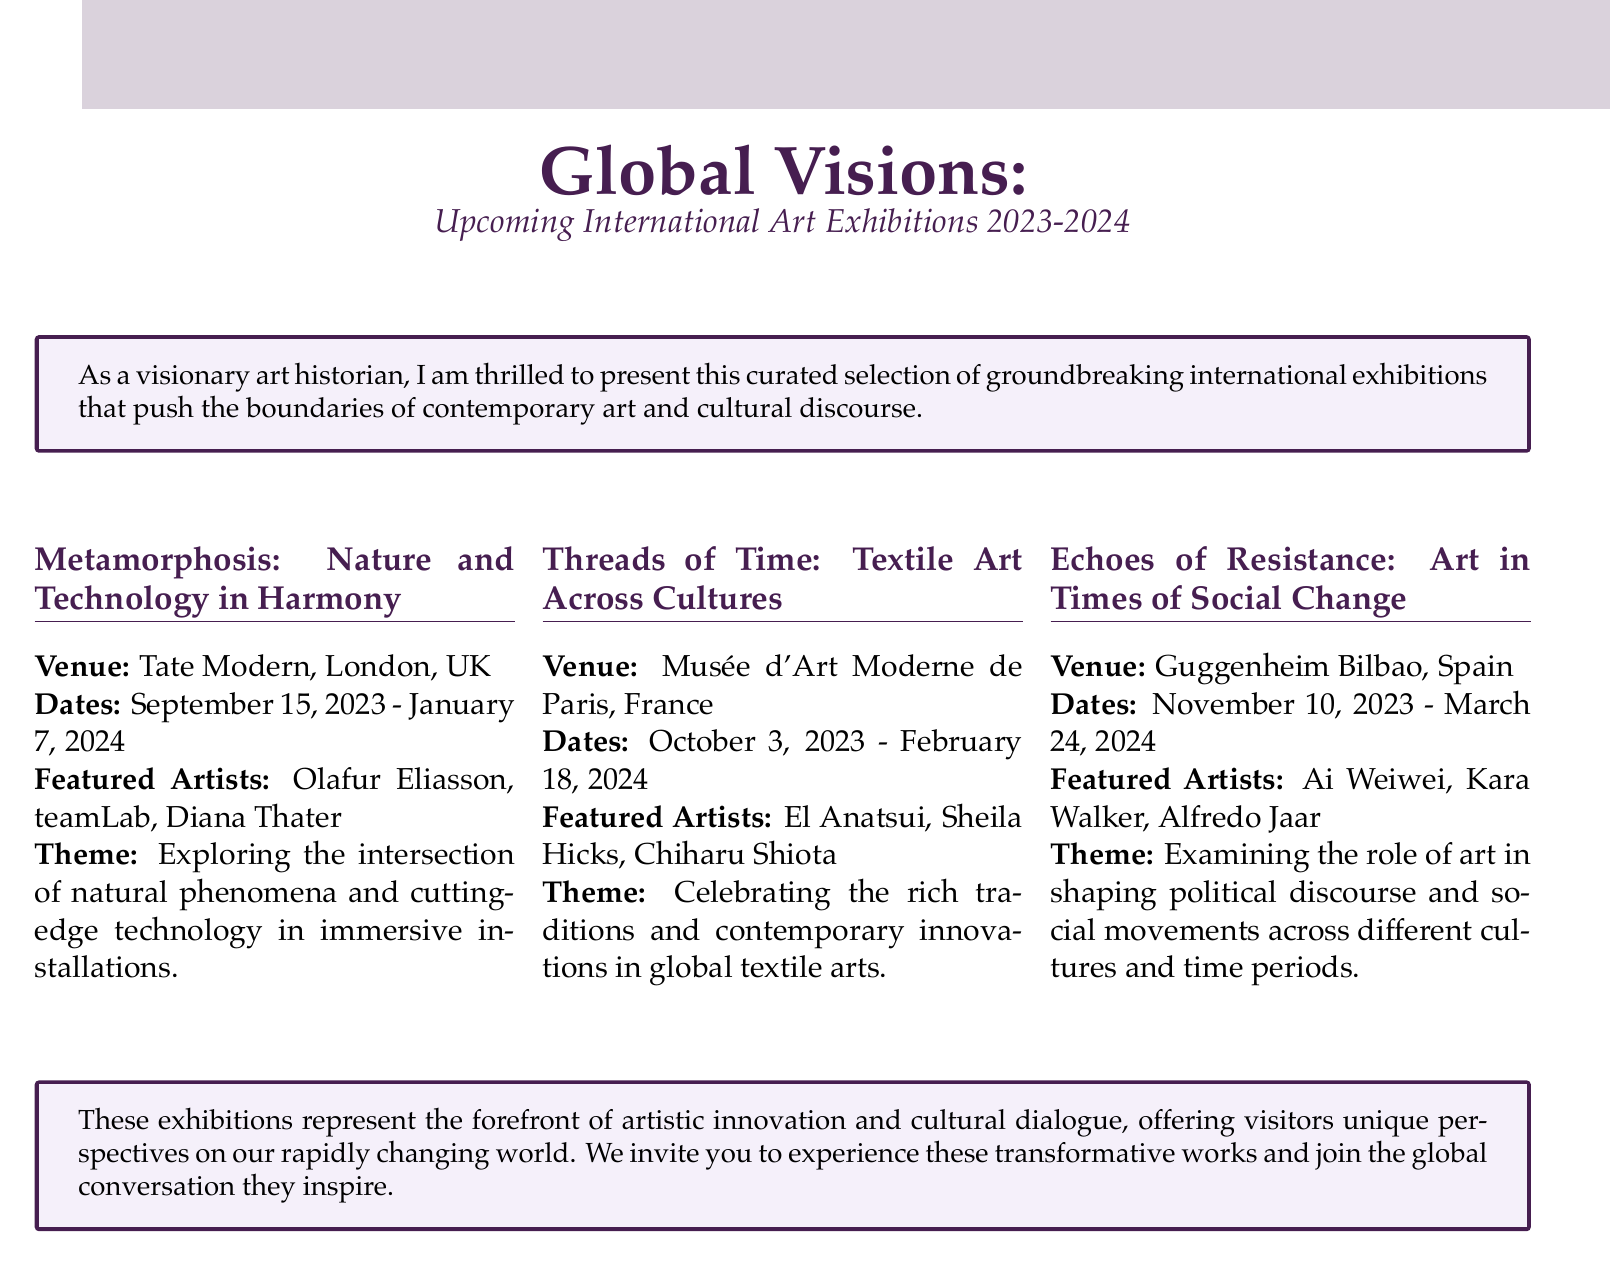What is the title of the catalog? The title is presented at the top of the document, summarizing its content.
Answer: Global Visions: Upcoming International Art Exhibitions 2023-2024 How long will the exhibition at Tate Modern be open? The document states the opening and closing dates for the exhibition at Tate Modern.
Answer: 115 days Who is a featured artist in the "Metamorphosis" exhibition? The document lists several artists featured in the exhibition at Tate Modern.
Answer: Olafur Eliasson What is the theme of the exhibition at the Musée d'Art Moderne de Paris? The theme is specified for each exhibition, providing insight into its focus.
Answer: Celebrating the rich traditions and contemporary innovations in global textile arts Which venue hosts the "Echoes of Resistance" exhibition? The venue is clearly mentioned in the context of each exhibition.
Answer: Guggenheim Bilbao How many featured artists are listed for the "Threads of Time" exhibition? The document provides the number of artists listed under each exhibition's featured artists section.
Answer: 3 What dates does the "Echoes of Resistance" exhibition run? The document specifies the start and end dates for this exhibition.
Answer: November 10, 2023 - March 24, 2024 Which artist is featured in the "Echoes of Resistance" exhibition? The document indicates notable artists associated with this exhibition.
Answer: Ai Weiwei What kind of themes do these exhibitions represent? The overarching idea of the exhibitions is outlined in the introduction and subsequent descriptions.
Answer: Artistic innovation and cultural dialogue 